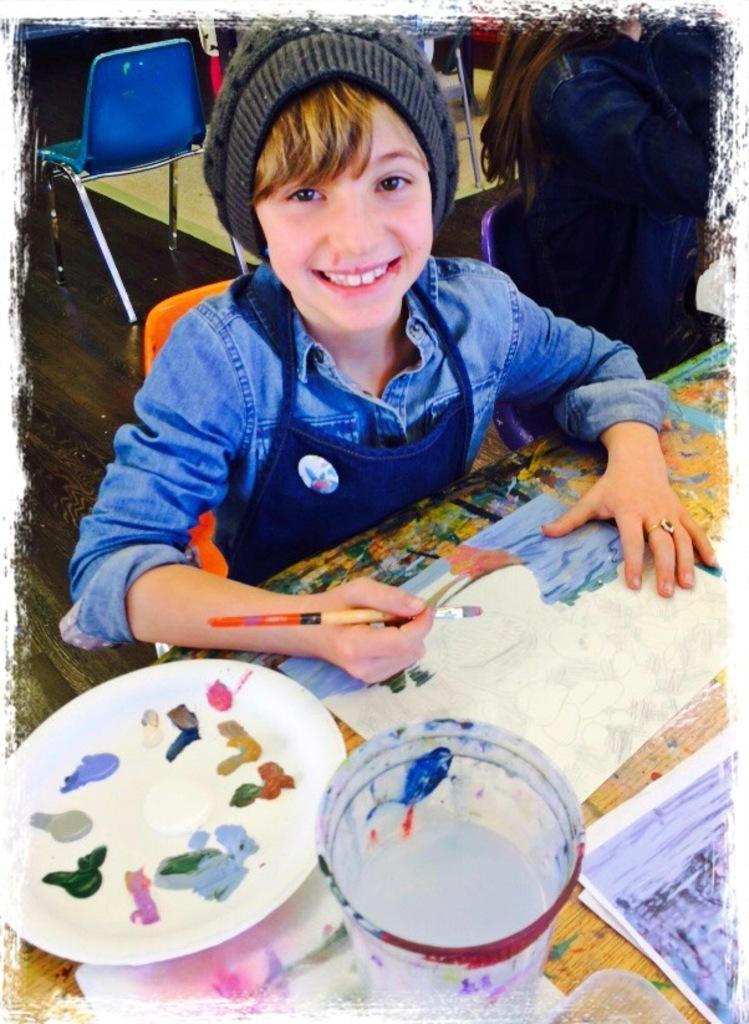Can you describe this image briefly? This looks like an edited image. I can see two people sitting. This person is smiling and holding a paint brush. I can see a table with a plate of colour, papers, glass of water and few other things on it. I think this person is painting on a paper. At the top of the image, I can see a chair on the floor. 